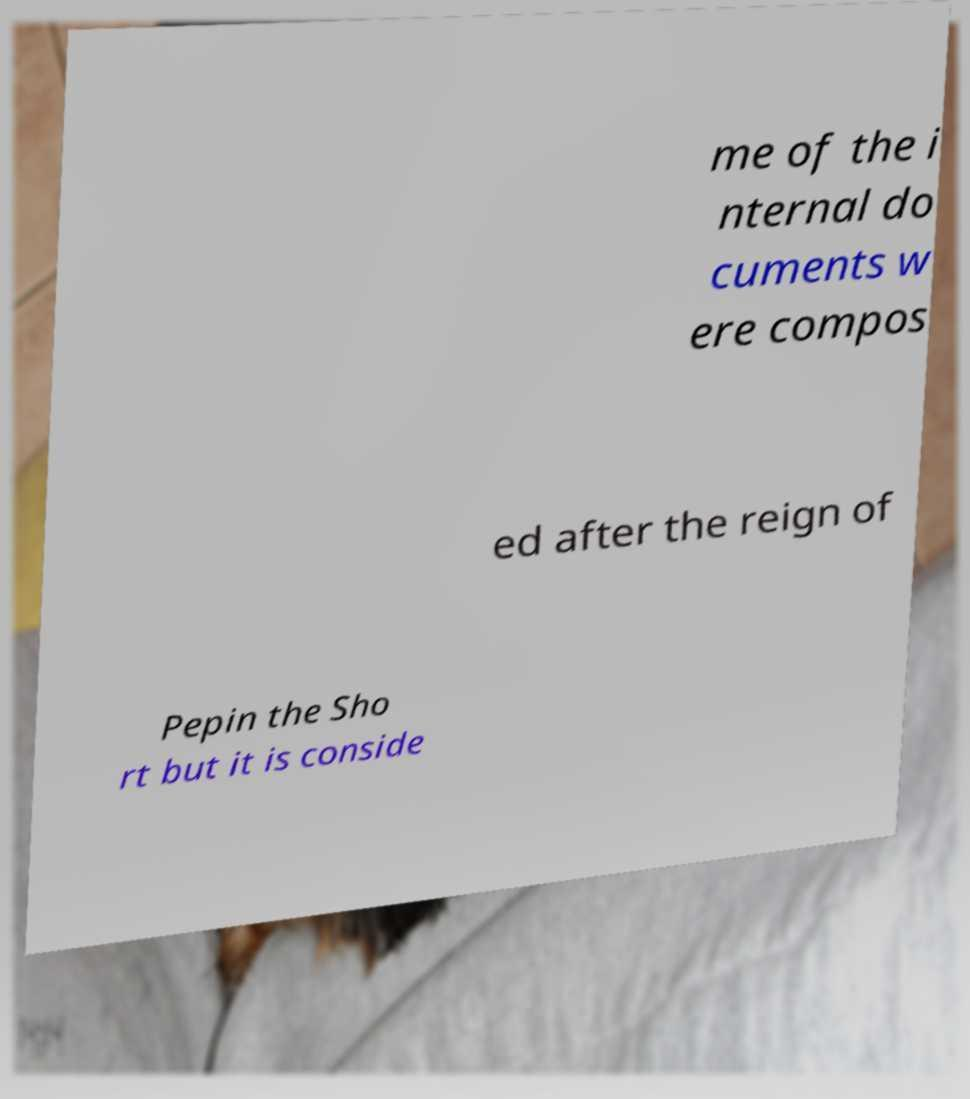What messages or text are displayed in this image? I need them in a readable, typed format. me of the i nternal do cuments w ere compos ed after the reign of Pepin the Sho rt but it is conside 